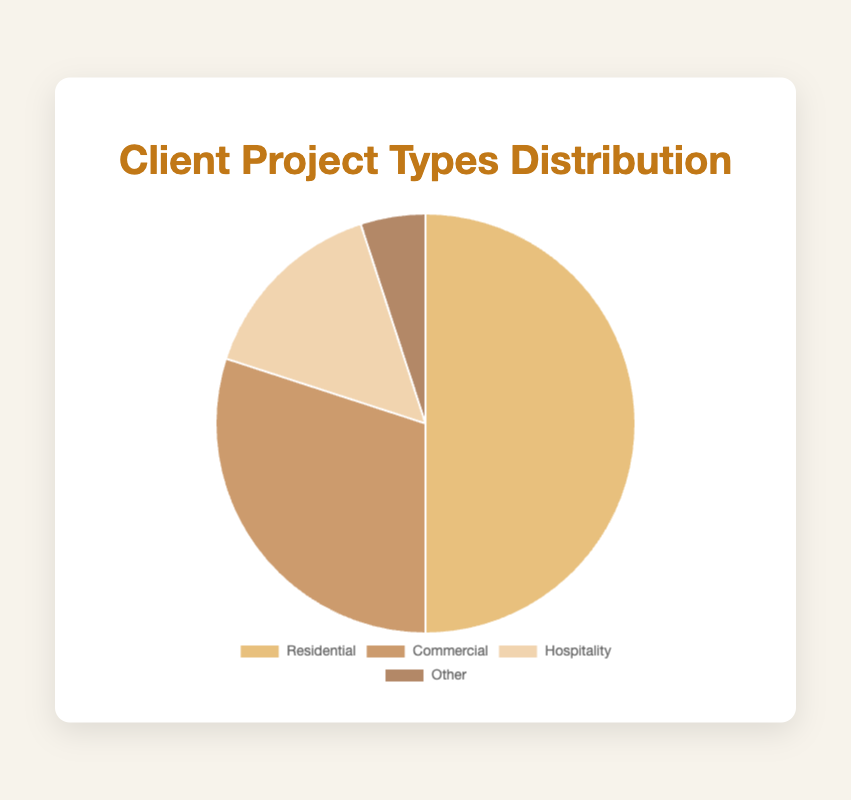Which project type has the highest percentage? The project type with the highest percentage in the pie chart is visually the largest slice, and the label shows it is Residential with 50%.
Answer: Residential How much more percentage does the Commercial type have compared to the Other type? To find how much more percentage the Commercial type has compared to the Other type, subtract the percentage of Other (5%) from the percentage of Commercial (30%). 30% - 5% = 25%
Answer: 25% What is the combined percentage of Residential and Hospitality projects? To find the combined percentage of Residential and Hospitality projects, add the percentage of Residential (50%) to the percentage of Hospitality (15%). 50% + 15% = 65%
Answer: 65% Which two project types combined make up half (50%) of the total projects? To find which two project types combined make up 50% of the total projects, we check different combinations. Residential (50%) alone fits this criterion.
Answer: Residential What is the difference in the percentage between the largest and the smallest project types? To find the difference in percentage between the largest and smallest project types, subtract the smallest (Other, 5%) from the largest (Residential, 50%). 50% - 5% = 45%
Answer: 45% Which project type makes up 30% of the total projects? The pie chart's segment labeled Commercial represents 30% of the total projects.
Answer: Commercial What color represents the Hospitality project type in the pie chart? The slice representing Hospitality in the pie chart is colored a lighter brown shade, observable in the legend or the pie segment itself.
Answer: Light brown If you combine Commercial and Other projects, what portion of the total projects do they make? Adding the percentages of Commercial (30%) and Other (5%) gives you 30% + 5% = 35%. So, together these projects make up 35% of the total.
Answer: 35% How does the percentage of Hospitality projects compare to that of Commercial projects? The Hospitality project type makes up 15% while the Commercial project type accounts for 30%, so Hospitality is half the percentage of Commercial.
Answer: Half 